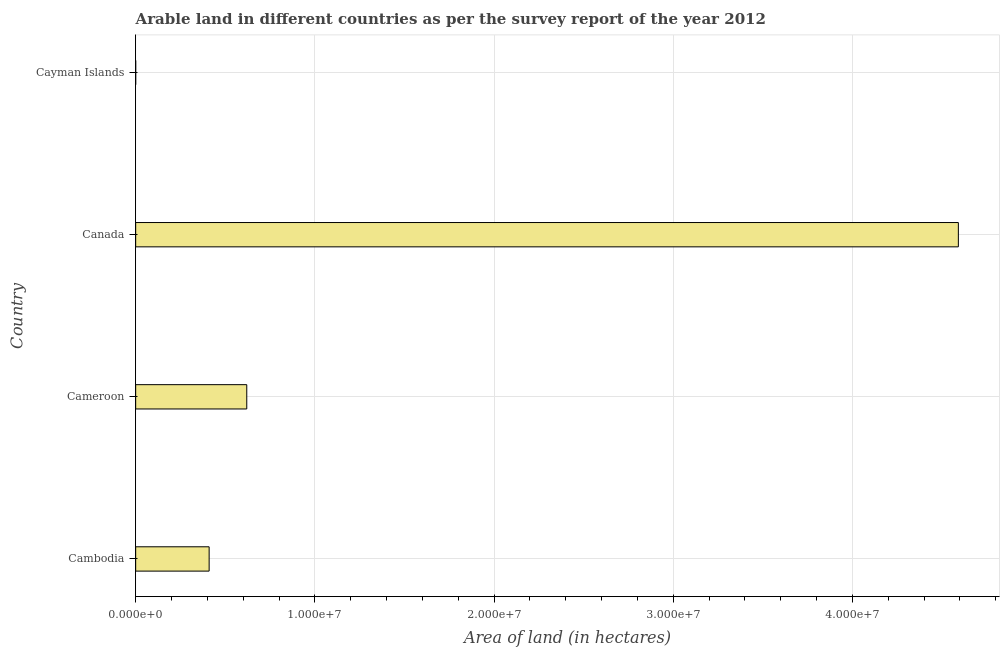What is the title of the graph?
Offer a terse response. Arable land in different countries as per the survey report of the year 2012. What is the label or title of the X-axis?
Keep it short and to the point. Area of land (in hectares). What is the label or title of the Y-axis?
Offer a terse response. Country. What is the area of land in Canada?
Give a very brief answer. 4.59e+07. Across all countries, what is the maximum area of land?
Make the answer very short. 4.59e+07. In which country was the area of land minimum?
Your answer should be compact. Cayman Islands. What is the sum of the area of land?
Make the answer very short. 5.62e+07. What is the difference between the area of land in Cameroon and Cayman Islands?
Provide a short and direct response. 6.20e+06. What is the average area of land per country?
Give a very brief answer. 1.41e+07. What is the median area of land?
Give a very brief answer. 5.15e+06. What is the ratio of the area of land in Cambodia to that in Canada?
Keep it short and to the point. 0.09. What is the difference between the highest and the second highest area of land?
Give a very brief answer. 3.97e+07. What is the difference between the highest and the lowest area of land?
Your response must be concise. 4.59e+07. In how many countries, is the area of land greater than the average area of land taken over all countries?
Ensure brevity in your answer.  1. Are all the bars in the graph horizontal?
Offer a terse response. Yes. How many countries are there in the graph?
Give a very brief answer. 4. Are the values on the major ticks of X-axis written in scientific E-notation?
Your answer should be compact. Yes. What is the Area of land (in hectares) in Cambodia?
Keep it short and to the point. 4.10e+06. What is the Area of land (in hectares) in Cameroon?
Make the answer very short. 6.20e+06. What is the Area of land (in hectares) in Canada?
Your answer should be compact. 4.59e+07. What is the Area of land (in hectares) of Cayman Islands?
Offer a very short reply. 200. What is the difference between the Area of land (in hectares) in Cambodia and Cameroon?
Your answer should be compact. -2.10e+06. What is the difference between the Area of land (in hectares) in Cambodia and Canada?
Ensure brevity in your answer.  -4.18e+07. What is the difference between the Area of land (in hectares) in Cambodia and Cayman Islands?
Your answer should be compact. 4.10e+06. What is the difference between the Area of land (in hectares) in Cameroon and Canada?
Make the answer very short. -3.97e+07. What is the difference between the Area of land (in hectares) in Cameroon and Cayman Islands?
Your answer should be very brief. 6.20e+06. What is the difference between the Area of land (in hectares) in Canada and Cayman Islands?
Provide a succinct answer. 4.59e+07. What is the ratio of the Area of land (in hectares) in Cambodia to that in Cameroon?
Offer a very short reply. 0.66. What is the ratio of the Area of land (in hectares) in Cambodia to that in Canada?
Give a very brief answer. 0.09. What is the ratio of the Area of land (in hectares) in Cambodia to that in Cayman Islands?
Keep it short and to the point. 2.05e+04. What is the ratio of the Area of land (in hectares) in Cameroon to that in Canada?
Make the answer very short. 0.14. What is the ratio of the Area of land (in hectares) in Cameroon to that in Cayman Islands?
Ensure brevity in your answer.  3.10e+04. What is the ratio of the Area of land (in hectares) in Canada to that in Cayman Islands?
Provide a succinct answer. 2.30e+05. 